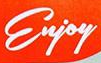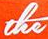What text appears in these images from left to right, separated by a semicolon? Enjoy; the 